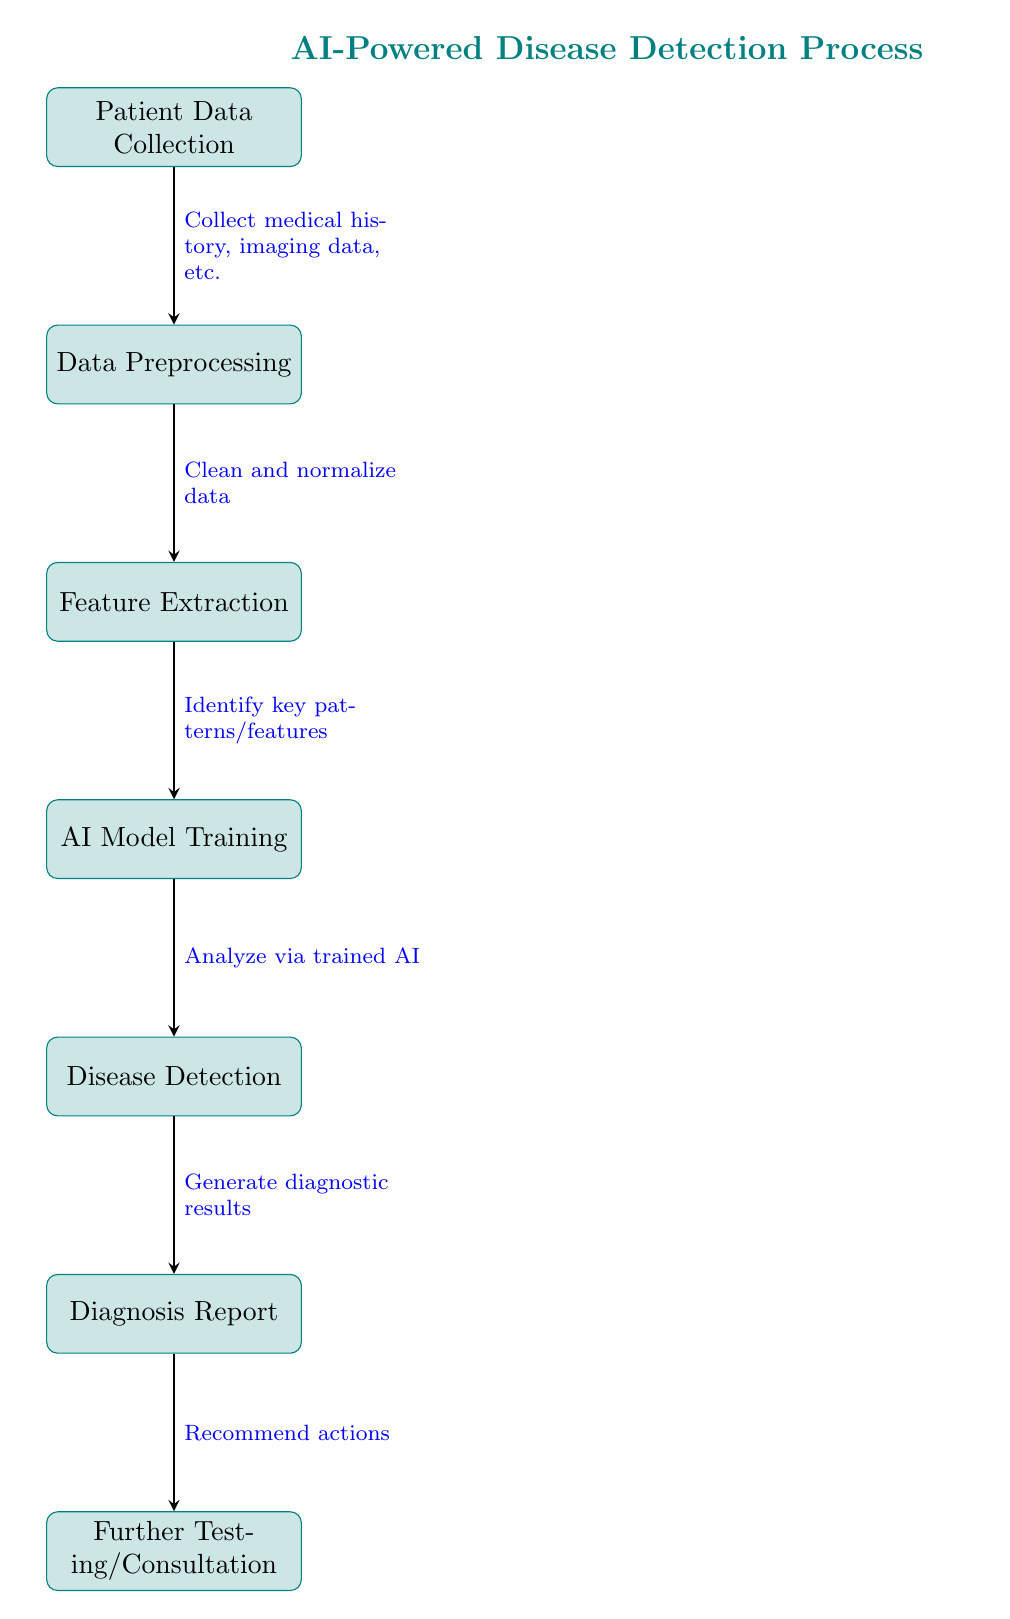What is the first step in the AI-powered disease detection process? The diagram shows "Patient Data Collection" as the first step, indicating that collecting patient information is where the process begins.
Answer: Patient Data Collection How many total steps are there in the disease detection process? The diagram outlines a total of 7 steps that the disease detection process follows, from "Patient Data Collection" to "Further Testing/Consultation."
Answer: 7 What type of data is involved in the second step? The second step, "Data Preprocessing," involves cleaning and normalizing the data that has been collected, as indicated by the annotation.
Answer: Cleaning and normalizing data What does the AI model do in the fourth step? In the fourth step, "AI Model Training," the AI analyzes the data using a trained model to identify key patterns, as stated in the diagram's annotation.
Answer: Analyze via trained AI What step follows the generation of the diagnosis report? After the "Diagnosis Report" is generated, the next step according to the flowchart is "Further Testing/Consultation," indicating what occurs after a report is produced.
Answer: Further Testing/Consultation Which process identifies key patterns and features? "Feature Extraction" is the third step where key patterns and features are identified, based on the visual flow shown in the diagram.
Answer: Feature Extraction What is the main purpose of the final step in the process? The final step, "Further Testing/Consultation," aims to recommend actions based on the diagnosis report, as stated in the diagram's flowchart.
Answer: Recommend actions 